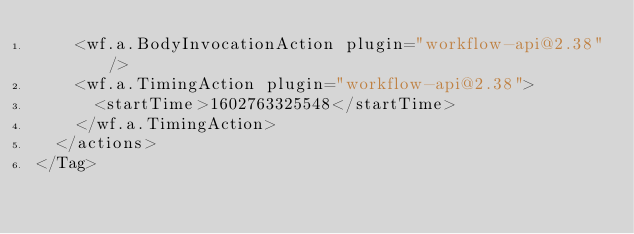Convert code to text. <code><loc_0><loc_0><loc_500><loc_500><_XML_>    <wf.a.BodyInvocationAction plugin="workflow-api@2.38"/>
    <wf.a.TimingAction plugin="workflow-api@2.38">
      <startTime>1602763325548</startTime>
    </wf.a.TimingAction>
  </actions>
</Tag></code> 